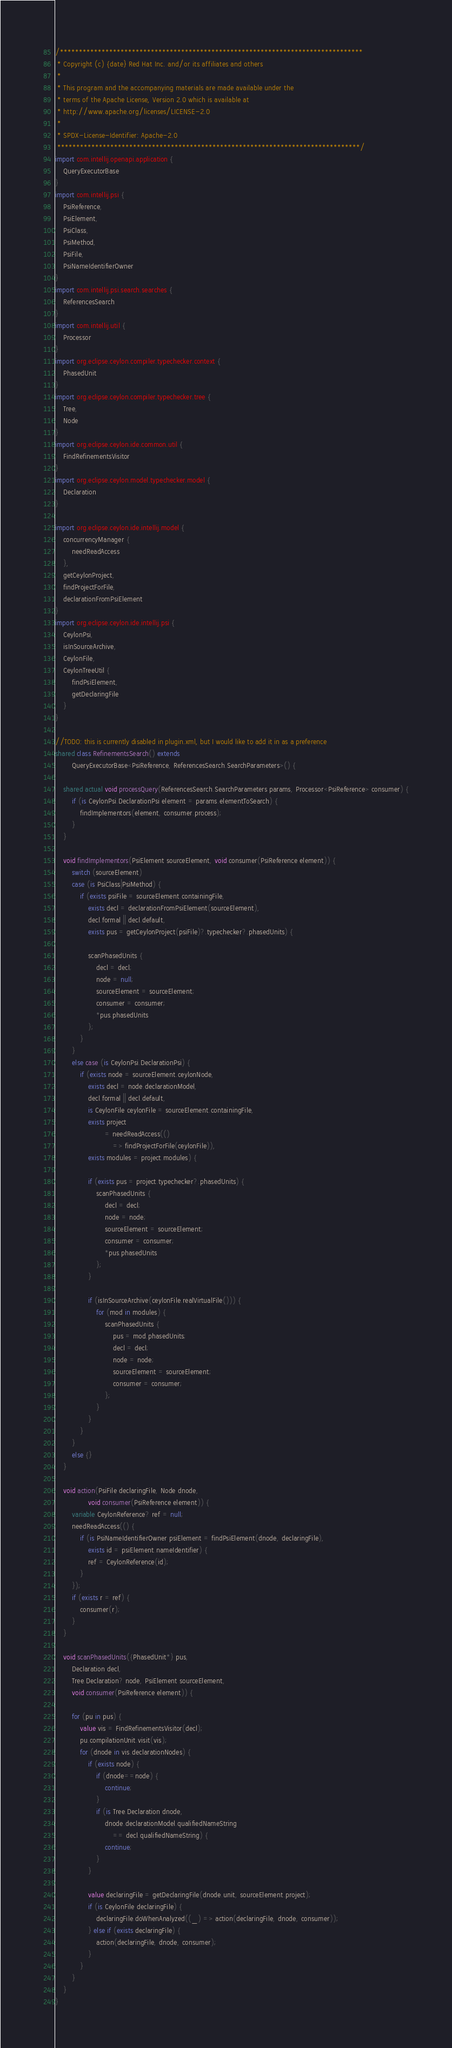Convert code to text. <code><loc_0><loc_0><loc_500><loc_500><_Ceylon_>/********************************************************************************
 * Copyright (c) {date} Red Hat Inc. and/or its affiliates and others
 *
 * This program and the accompanying materials are made available under the 
 * terms of the Apache License, Version 2.0 which is available at
 * http://www.apache.org/licenses/LICENSE-2.0
 *
 * SPDX-License-Identifier: Apache-2.0 
 ********************************************************************************/
import com.intellij.openapi.application {
    QueryExecutorBase
}
import com.intellij.psi {
    PsiReference,
    PsiElement,
    PsiClass,
    PsiMethod,
    PsiFile,
    PsiNameIdentifierOwner
}
import com.intellij.psi.search.searches {
    ReferencesSearch
}
import com.intellij.util {
    Processor
}
import org.eclipse.ceylon.compiler.typechecker.context {
    PhasedUnit
}
import org.eclipse.ceylon.compiler.typechecker.tree {
    Tree,
    Node
}
import org.eclipse.ceylon.ide.common.util {
    FindRefinementsVisitor
}
import org.eclipse.ceylon.model.typechecker.model {
    Declaration
}

import org.eclipse.ceylon.ide.intellij.model {
    concurrencyManager {
        needReadAccess
    },
    getCeylonProject,
    findProjectForFile,
    declarationFromPsiElement
}
import org.eclipse.ceylon.ide.intellij.psi {
    CeylonPsi,
    isInSourceArchive,
    CeylonFile,
    CeylonTreeUtil {
        findPsiElement,
        getDeclaringFile
    }
}

//TODO: this is currently disabled in plugin.xml, but I would like to add it in as a preference
shared class RefinementsSearch() extends
        QueryExecutorBase<PsiReference, ReferencesSearch.SearchParameters>() {

    shared actual void processQuery(ReferencesSearch.SearchParameters params, Processor<PsiReference> consumer) {
        if (is CeylonPsi.DeclarationPsi element = params.elementToSearch) {
            findImplementors(element, consumer.process);
        }
    }

    void findImplementors(PsiElement sourceElement, void consumer(PsiReference element)) {
        switch (sourceElement)
        case (is PsiClass|PsiMethod) {
            if (exists psiFile = sourceElement.containingFile,
                exists decl = declarationFromPsiElement(sourceElement),
                decl.formal || decl.default,
                exists pus = getCeylonProject(psiFile)?.typechecker?.phasedUnits) {

                scanPhasedUnits {
                    decl = decl;
                    node = null;
                    sourceElement = sourceElement;
                    consumer = consumer;
                    *pus.phasedUnits
                };
            }
        }
        else case (is CeylonPsi.DeclarationPsi) {
            if (exists node = sourceElement.ceylonNode,
                exists decl = node.declarationModel,
                decl.formal || decl.default,
                is CeylonFile ceylonFile = sourceElement.containingFile,
                exists project
                        = needReadAccess(()
                            => findProjectForFile(ceylonFile)),
                exists modules = project.modules) {

                if (exists pus = project.typechecker?.phasedUnits) {
                    scanPhasedUnits {
                        decl = decl;
                        node = node;
                        sourceElement = sourceElement;
                        consumer = consumer;
                        *pus.phasedUnits
                    };
                }

                if (isInSourceArchive(ceylonFile.realVirtualFile())) {
                    for (mod in modules) {
                        scanPhasedUnits {
                            pus = mod.phasedUnits;
                            decl = decl;
                            node = node;
                            sourceElement = sourceElement;
                            consumer = consumer;
                        };
                    }
                }
            }
        }
        else {}
    }

    void action(PsiFile declaringFile, Node dnode,
                void consumer(PsiReference element)) {
        variable CeylonReference? ref = null;
        needReadAccess(() {
            if (is PsiNameIdentifierOwner psiElement = findPsiElement(dnode, declaringFile),
                exists id = psiElement.nameIdentifier) {
                ref = CeylonReference(id);
            }
        });
        if (exists r = ref) {
            consumer(r);
        }
    }

    void scanPhasedUnits({PhasedUnit*} pus,
        Declaration decl,
        Tree.Declaration? node, PsiElement sourceElement,
        void consumer(PsiReference element)) {

        for (pu in pus) {
            value vis = FindRefinementsVisitor(decl);
            pu.compilationUnit.visit(vis);
            for (dnode in vis.declarationNodes) {
                if (exists node) {
                    if (dnode==node) {
                        continue;
                    }
                    if (is Tree.Declaration dnode,
                        dnode.declarationModel.qualifiedNameString
                            == decl.qualifiedNameString) {
                        continue;
                    }
                }

                value declaringFile = getDeclaringFile(dnode.unit, sourceElement.project);
                if (is CeylonFile declaringFile) {
                    declaringFile.doWhenAnalyzed((_) => action(declaringFile, dnode, consumer));
                } else if (exists declaringFile) {
                    action(declaringFile, dnode, consumer);
                }
            }
        }
    }
}

</code> 